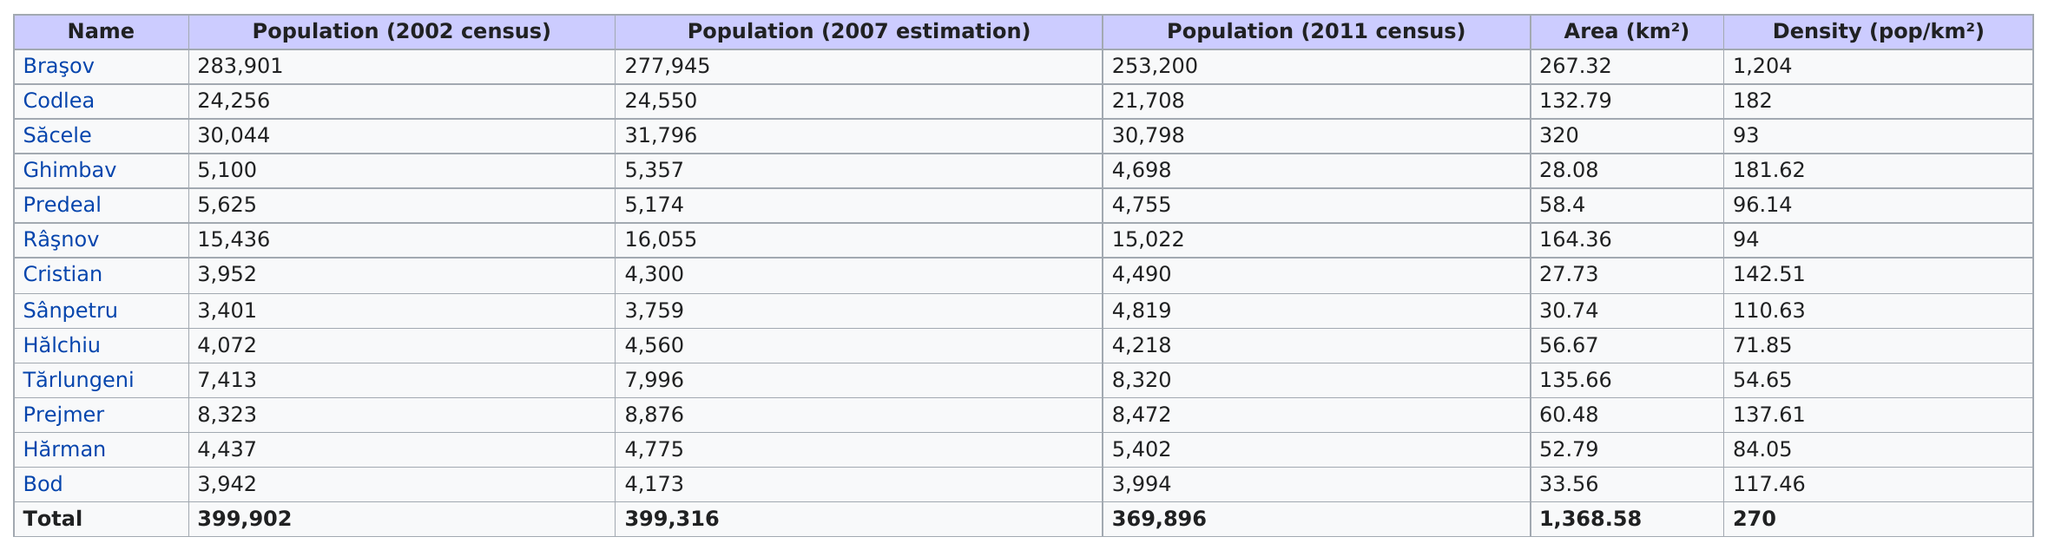Identify some key points in this picture. I declare that the city with the highest density is Braşov. In 2007, the estimated number of inhabitants living in Predeal was 5,174. According to the chart, the locality with the least amount of area is Cristian. According to the 2011 census, Braşov was the city with the highest population. In 2002, Rasnov had more than 10,000 people. Yes, it is true. 